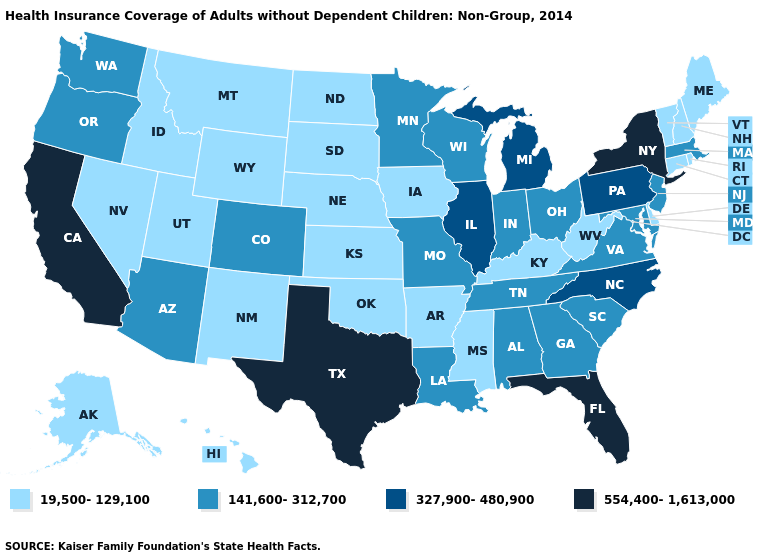Does Virginia have the lowest value in the USA?
Short answer required. No. Which states have the highest value in the USA?
Keep it brief. California, Florida, New York, Texas. Is the legend a continuous bar?
Concise answer only. No. What is the value of Oklahoma?
Answer briefly. 19,500-129,100. Which states have the lowest value in the West?
Short answer required. Alaska, Hawaii, Idaho, Montana, Nevada, New Mexico, Utah, Wyoming. Name the states that have a value in the range 141,600-312,700?
Quick response, please. Alabama, Arizona, Colorado, Georgia, Indiana, Louisiana, Maryland, Massachusetts, Minnesota, Missouri, New Jersey, Ohio, Oregon, South Carolina, Tennessee, Virginia, Washington, Wisconsin. Name the states that have a value in the range 554,400-1,613,000?
Short answer required. California, Florida, New York, Texas. Name the states that have a value in the range 554,400-1,613,000?
Short answer required. California, Florida, New York, Texas. Does California have a higher value than Florida?
Answer briefly. No. Does Iowa have a higher value than Texas?
Keep it brief. No. Does Colorado have a lower value than Kentucky?
Answer briefly. No. What is the lowest value in the West?
Answer briefly. 19,500-129,100. Does Pennsylvania have the same value as Illinois?
Be succinct. Yes. Does Massachusetts have the lowest value in the Northeast?
Quick response, please. No. Which states have the lowest value in the USA?
Quick response, please. Alaska, Arkansas, Connecticut, Delaware, Hawaii, Idaho, Iowa, Kansas, Kentucky, Maine, Mississippi, Montana, Nebraska, Nevada, New Hampshire, New Mexico, North Dakota, Oklahoma, Rhode Island, South Dakota, Utah, Vermont, West Virginia, Wyoming. 